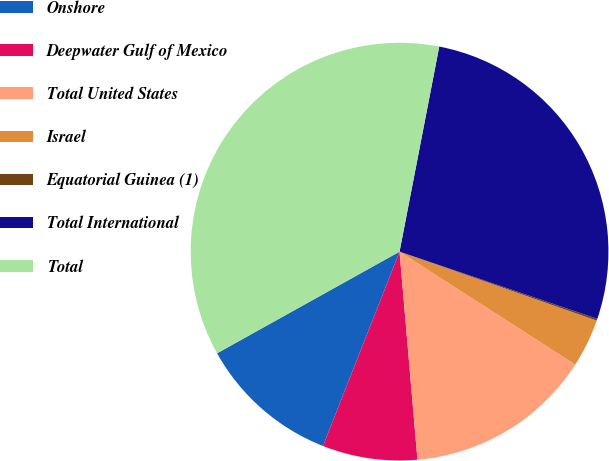Convert chart to OTSL. <chart><loc_0><loc_0><loc_500><loc_500><pie_chart><fcel>Onshore<fcel>Deepwater Gulf of Mexico<fcel>Total United States<fcel>Israel<fcel>Equatorial Guinea (1)<fcel>Total International<fcel>Total<nl><fcel>10.94%<fcel>7.34%<fcel>14.54%<fcel>3.74%<fcel>0.14%<fcel>27.17%<fcel>36.13%<nl></chart> 